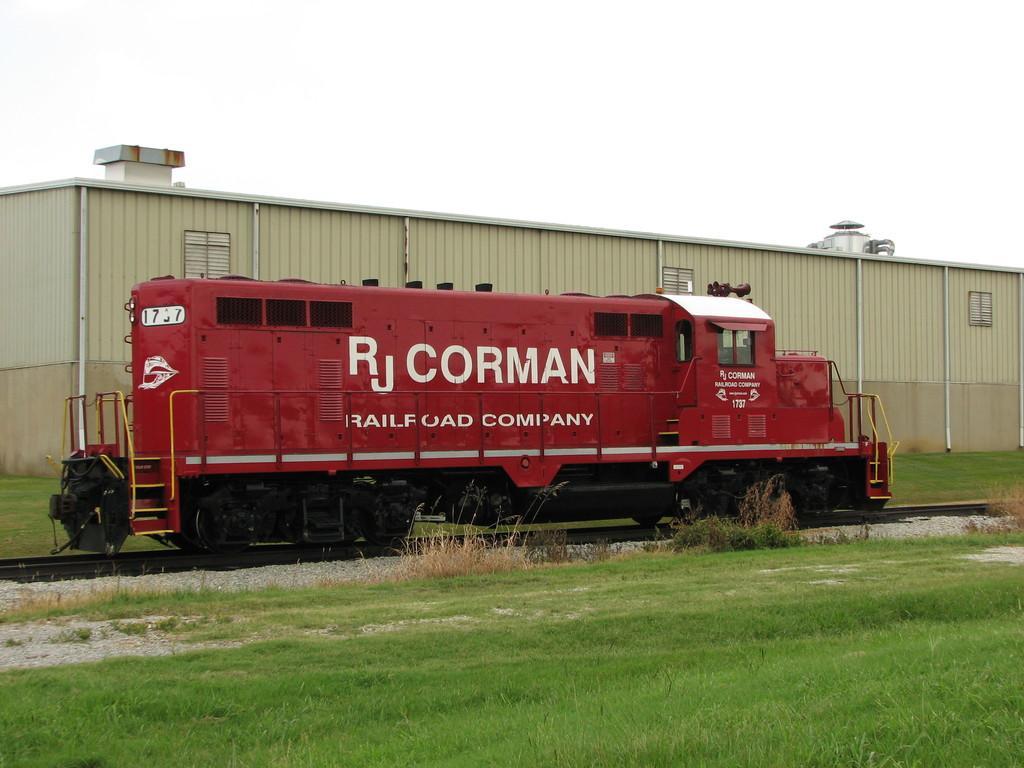Could you give a brief overview of what you see in this image? In this image I see a train engine which is of red in color and I see something is written on it and I see the tracks and I see the grass. In the background I see the sky and I see the containers. 